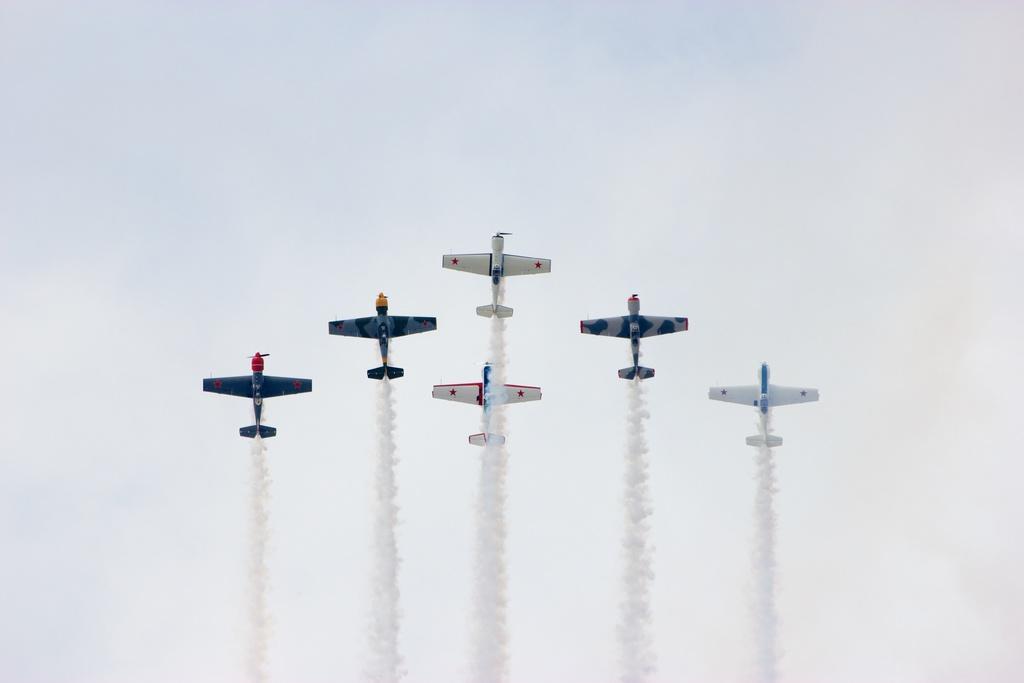Please provide a concise description of this image. In the middle of the image we can see some planes and air pollution. Behind the planes we can see some clouds in the sky. 